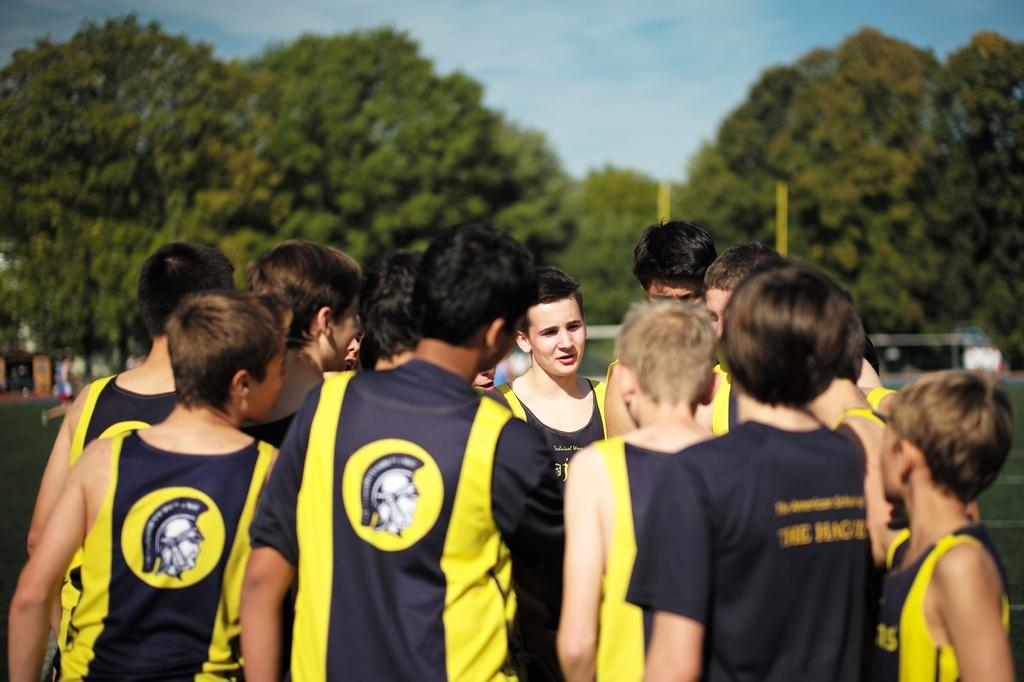What can be seen in the image? There are people standing in the image. What type of natural environment is visible in the image? There are trees visible in the image. How would you describe the sky in the image? The sky is blue and cloudy in the image. What color paint is being used on the coat in the image? There is no coat or paint present in the image; it features people standing near trees with a blue and cloudy sky. 